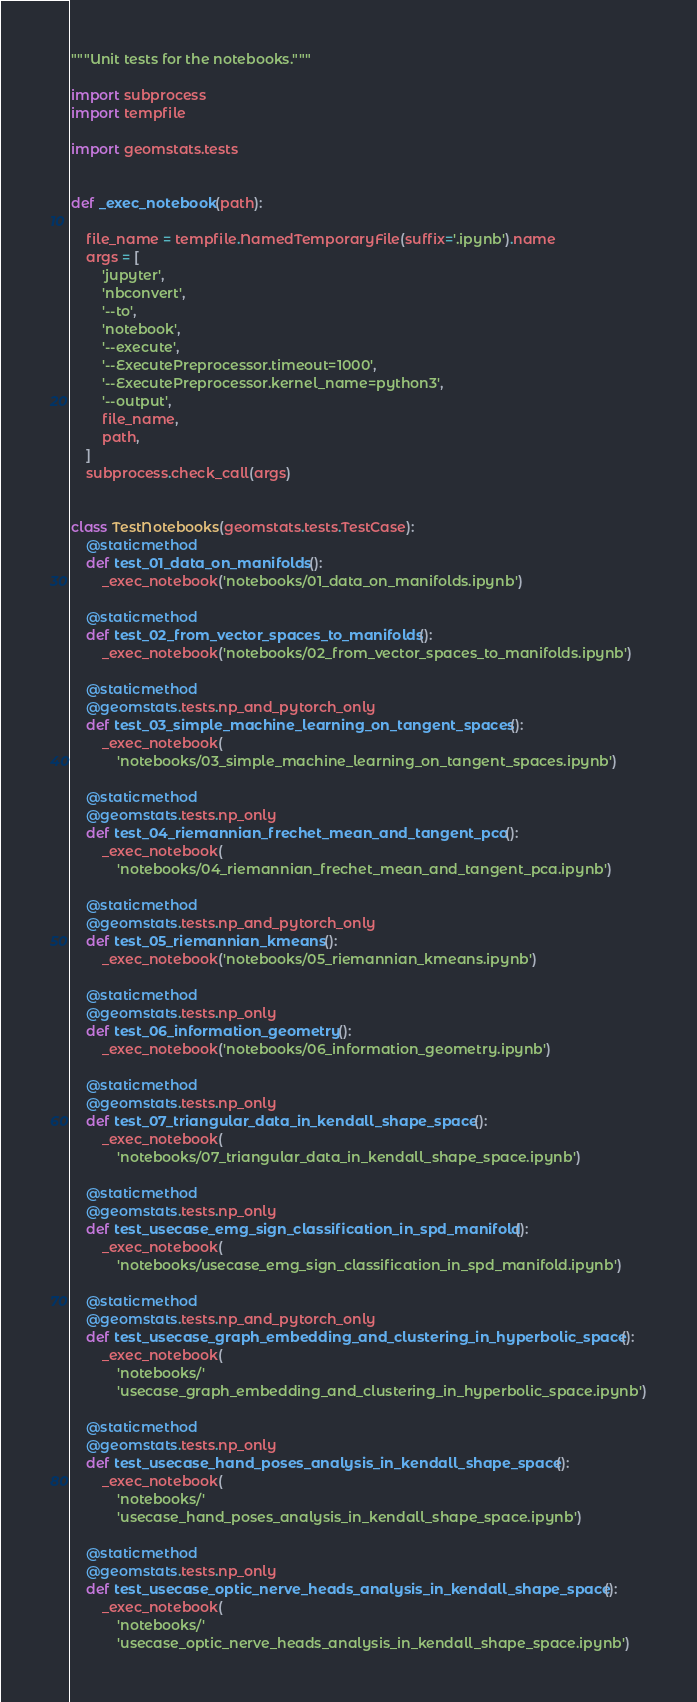<code> <loc_0><loc_0><loc_500><loc_500><_Python_>"""Unit tests for the notebooks."""

import subprocess
import tempfile

import geomstats.tests


def _exec_notebook(path):

    file_name = tempfile.NamedTemporaryFile(suffix='.ipynb').name
    args = [
        'jupyter',
        'nbconvert',
        '--to',
        'notebook',
        '--execute',
        '--ExecutePreprocessor.timeout=1000',
        '--ExecutePreprocessor.kernel_name=python3',
        '--output',
        file_name,
        path,
    ]
    subprocess.check_call(args)


class TestNotebooks(geomstats.tests.TestCase):
    @staticmethod
    def test_01_data_on_manifolds():
        _exec_notebook('notebooks/01_data_on_manifolds.ipynb')

    @staticmethod
    def test_02_from_vector_spaces_to_manifolds():
        _exec_notebook('notebooks/02_from_vector_spaces_to_manifolds.ipynb')

    @staticmethod
    @geomstats.tests.np_and_pytorch_only
    def test_03_simple_machine_learning_on_tangent_spaces():
        _exec_notebook(
            'notebooks/03_simple_machine_learning_on_tangent_spaces.ipynb')

    @staticmethod
    @geomstats.tests.np_only
    def test_04_riemannian_frechet_mean_and_tangent_pca():
        _exec_notebook(
            'notebooks/04_riemannian_frechet_mean_and_tangent_pca.ipynb')

    @staticmethod
    @geomstats.tests.np_and_pytorch_only
    def test_05_riemannian_kmeans():
        _exec_notebook('notebooks/05_riemannian_kmeans.ipynb')

    @staticmethod
    @geomstats.tests.np_only
    def test_06_information_geometry():
        _exec_notebook('notebooks/06_information_geometry.ipynb')

    @staticmethod
    @geomstats.tests.np_only
    def test_07_triangular_data_in_kendall_shape_space():
        _exec_notebook(
            'notebooks/07_triangular_data_in_kendall_shape_space.ipynb')

    @staticmethod
    @geomstats.tests.np_only
    def test_usecase_emg_sign_classification_in_spd_manifold():
        _exec_notebook(
            'notebooks/usecase_emg_sign_classification_in_spd_manifold.ipynb')

    @staticmethod
    @geomstats.tests.np_and_pytorch_only
    def test_usecase_graph_embedding_and_clustering_in_hyperbolic_space():
        _exec_notebook(
            'notebooks/'
            'usecase_graph_embedding_and_clustering_in_hyperbolic_space.ipynb')

    @staticmethod
    @geomstats.tests.np_only
    def test_usecase_hand_poses_analysis_in_kendall_shape_space():
        _exec_notebook(
            'notebooks/'
            'usecase_hand_poses_analysis_in_kendall_shape_space.ipynb')

    @staticmethod
    @geomstats.tests.np_only
    def test_usecase_optic_nerve_heads_analysis_in_kendall_shape_space():
        _exec_notebook(
            'notebooks/'
            'usecase_optic_nerve_heads_analysis_in_kendall_shape_space.ipynb')
</code> 